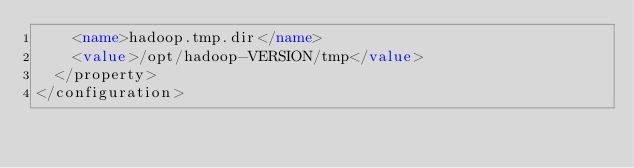<code> <loc_0><loc_0><loc_500><loc_500><_XML_>    <name>hadoop.tmp.dir</name>
    <value>/opt/hadoop-VERSION/tmp</value>
  </property>
</configuration></code> 